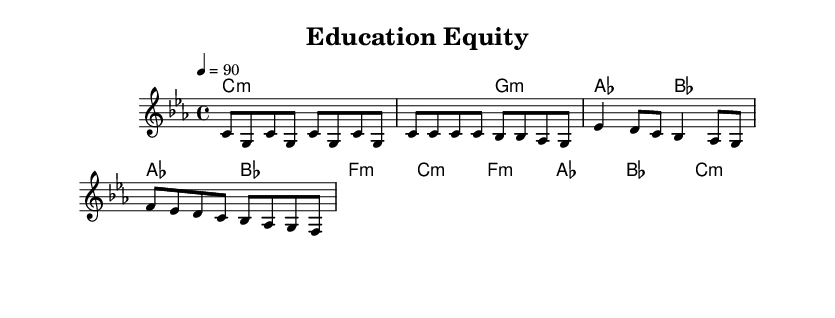What is the key signature of this music? The key signature is C minor, indicated by the presence of three flats (B-flat, E-flat, A-flat).
Answer: C minor What is the time signature of this music? The time signature is located at the beginning of the score and is written as 4/4, indicating four beats per measure.
Answer: 4/4 What is the tempo marking for this piece? The tempo marking is indicated in the score as "4 = 90," which specifies the speed at which the piece should be played.
Answer: 90 How many measures are in the verse section? By examining the melody and harmony in the verse, there are 4 measures in total, as each group of notes corresponds to a measure.
Answer: 4 What is the predominant musical texture used in this rap piece? The piece uses a combination of melody and harmonies to create a polyphonic texture typical for rap music, where rhythmic and melodic elements interact.
Answer: Polyphonic Which section features a change in dynamics? The bridge section indicates a dynamic shift, as seen in the varying note entries and overall intensity of the harmony and melody, common in rap compositions for emphasis.
Answer: Bridge What is the primary theme addressed in the lyrics of this rap? The lyrics focus on the theme of education equity, highlighting social justice issues related to health disparities in urban settings, which is a common topic in socially conscious rap.
Answer: Education equity 